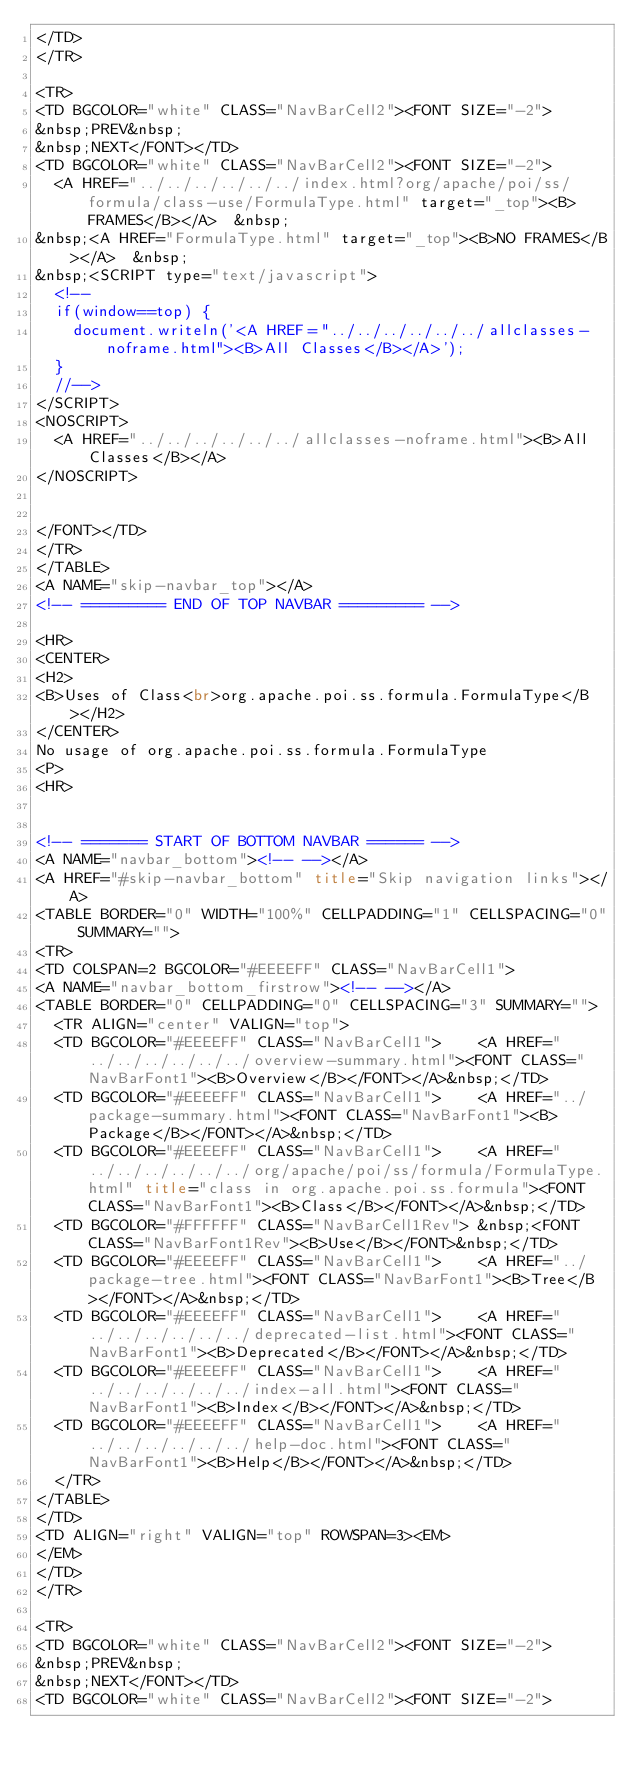Convert code to text. <code><loc_0><loc_0><loc_500><loc_500><_HTML_></TD>
</TR>

<TR>
<TD BGCOLOR="white" CLASS="NavBarCell2"><FONT SIZE="-2">
&nbsp;PREV&nbsp;
&nbsp;NEXT</FONT></TD>
<TD BGCOLOR="white" CLASS="NavBarCell2"><FONT SIZE="-2">
  <A HREF="../../../../../../index.html?org/apache/poi/ss/formula/class-use/FormulaType.html" target="_top"><B>FRAMES</B></A>  &nbsp;
&nbsp;<A HREF="FormulaType.html" target="_top"><B>NO FRAMES</B></A>  &nbsp;
&nbsp;<SCRIPT type="text/javascript">
  <!--
  if(window==top) {
    document.writeln('<A HREF="../../../../../../allclasses-noframe.html"><B>All Classes</B></A>');
  }
  //-->
</SCRIPT>
<NOSCRIPT>
  <A HREF="../../../../../../allclasses-noframe.html"><B>All Classes</B></A>
</NOSCRIPT>


</FONT></TD>
</TR>
</TABLE>
<A NAME="skip-navbar_top"></A>
<!-- ========= END OF TOP NAVBAR ========= -->

<HR>
<CENTER>
<H2>
<B>Uses of Class<br>org.apache.poi.ss.formula.FormulaType</B></H2>
</CENTER>
No usage of org.apache.poi.ss.formula.FormulaType
<P>
<HR>


<!-- ======= START OF BOTTOM NAVBAR ====== -->
<A NAME="navbar_bottom"><!-- --></A>
<A HREF="#skip-navbar_bottom" title="Skip navigation links"></A>
<TABLE BORDER="0" WIDTH="100%" CELLPADDING="1" CELLSPACING="0" SUMMARY="">
<TR>
<TD COLSPAN=2 BGCOLOR="#EEEEFF" CLASS="NavBarCell1">
<A NAME="navbar_bottom_firstrow"><!-- --></A>
<TABLE BORDER="0" CELLPADDING="0" CELLSPACING="3" SUMMARY="">
  <TR ALIGN="center" VALIGN="top">
  <TD BGCOLOR="#EEEEFF" CLASS="NavBarCell1">    <A HREF="../../../../../../overview-summary.html"><FONT CLASS="NavBarFont1"><B>Overview</B></FONT></A>&nbsp;</TD>
  <TD BGCOLOR="#EEEEFF" CLASS="NavBarCell1">    <A HREF="../package-summary.html"><FONT CLASS="NavBarFont1"><B>Package</B></FONT></A>&nbsp;</TD>
  <TD BGCOLOR="#EEEEFF" CLASS="NavBarCell1">    <A HREF="../../../../../../org/apache/poi/ss/formula/FormulaType.html" title="class in org.apache.poi.ss.formula"><FONT CLASS="NavBarFont1"><B>Class</B></FONT></A>&nbsp;</TD>
  <TD BGCOLOR="#FFFFFF" CLASS="NavBarCell1Rev"> &nbsp;<FONT CLASS="NavBarFont1Rev"><B>Use</B></FONT>&nbsp;</TD>
  <TD BGCOLOR="#EEEEFF" CLASS="NavBarCell1">    <A HREF="../package-tree.html"><FONT CLASS="NavBarFont1"><B>Tree</B></FONT></A>&nbsp;</TD>
  <TD BGCOLOR="#EEEEFF" CLASS="NavBarCell1">    <A HREF="../../../../../../deprecated-list.html"><FONT CLASS="NavBarFont1"><B>Deprecated</B></FONT></A>&nbsp;</TD>
  <TD BGCOLOR="#EEEEFF" CLASS="NavBarCell1">    <A HREF="../../../../../../index-all.html"><FONT CLASS="NavBarFont1"><B>Index</B></FONT></A>&nbsp;</TD>
  <TD BGCOLOR="#EEEEFF" CLASS="NavBarCell1">    <A HREF="../../../../../../help-doc.html"><FONT CLASS="NavBarFont1"><B>Help</B></FONT></A>&nbsp;</TD>
  </TR>
</TABLE>
</TD>
<TD ALIGN="right" VALIGN="top" ROWSPAN=3><EM>
</EM>
</TD>
</TR>

<TR>
<TD BGCOLOR="white" CLASS="NavBarCell2"><FONT SIZE="-2">
&nbsp;PREV&nbsp;
&nbsp;NEXT</FONT></TD>
<TD BGCOLOR="white" CLASS="NavBarCell2"><FONT SIZE="-2"></code> 